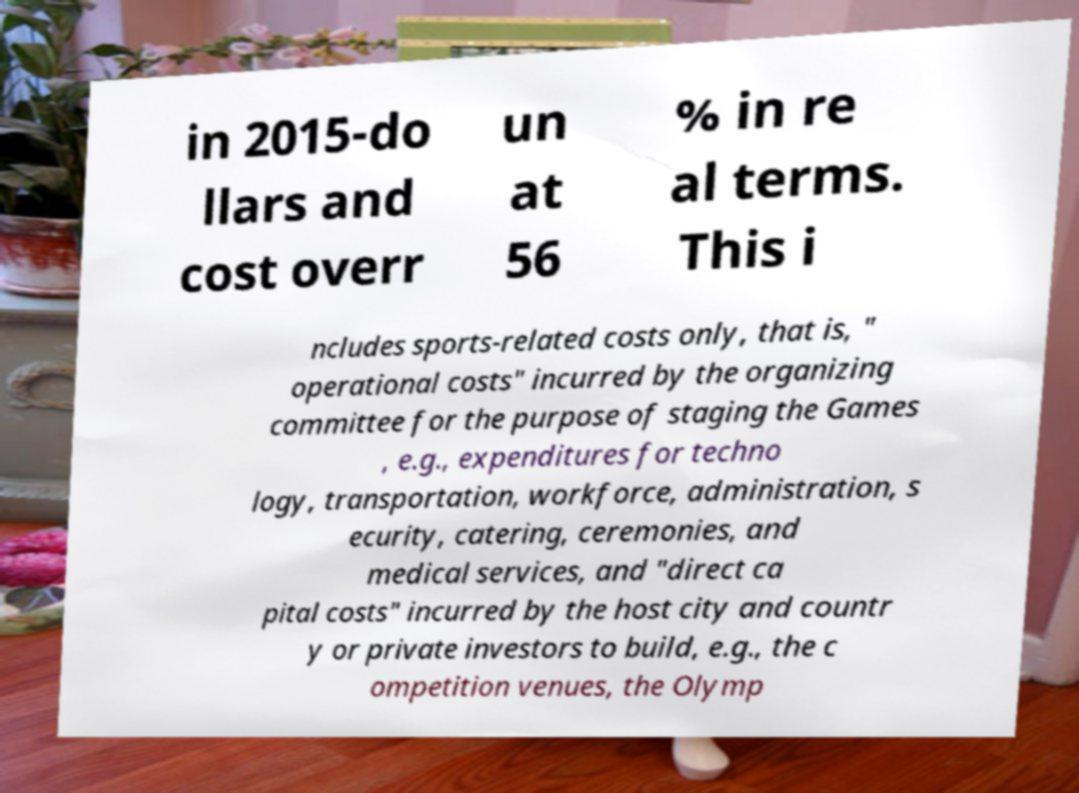Could you assist in decoding the text presented in this image and type it out clearly? in 2015-do llars and cost overr un at 56 % in re al terms. This i ncludes sports-related costs only, that is, " operational costs" incurred by the organizing committee for the purpose of staging the Games , e.g., expenditures for techno logy, transportation, workforce, administration, s ecurity, catering, ceremonies, and medical services, and "direct ca pital costs" incurred by the host city and countr y or private investors to build, e.g., the c ompetition venues, the Olymp 